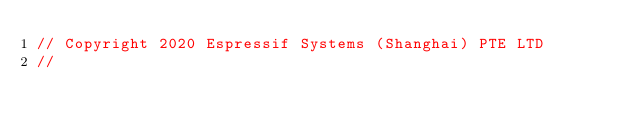Convert code to text. <code><loc_0><loc_0><loc_500><loc_500><_C_>// Copyright 2020 Espressif Systems (Shanghai) PTE LTD
//</code> 